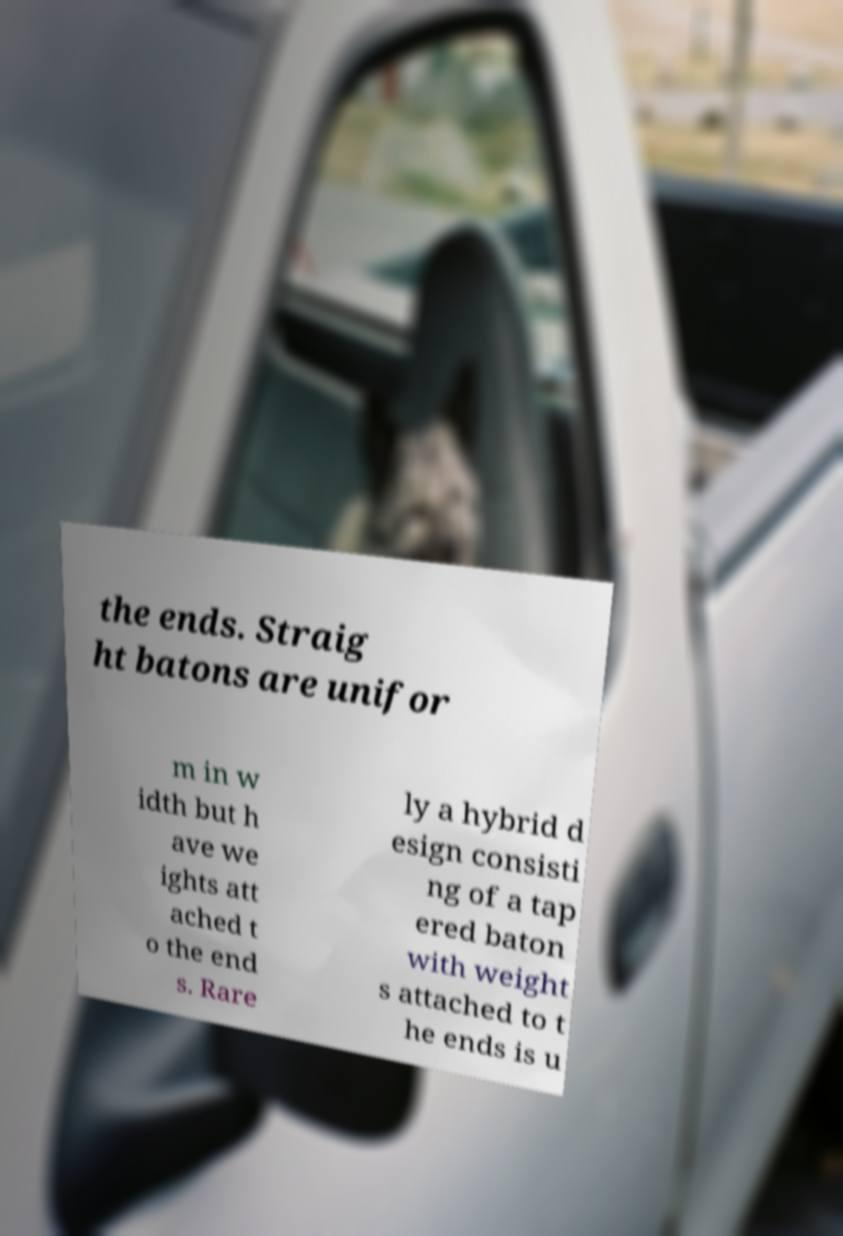Could you extract and type out the text from this image? the ends. Straig ht batons are unifor m in w idth but h ave we ights att ached t o the end s. Rare ly a hybrid d esign consisti ng of a tap ered baton with weight s attached to t he ends is u 